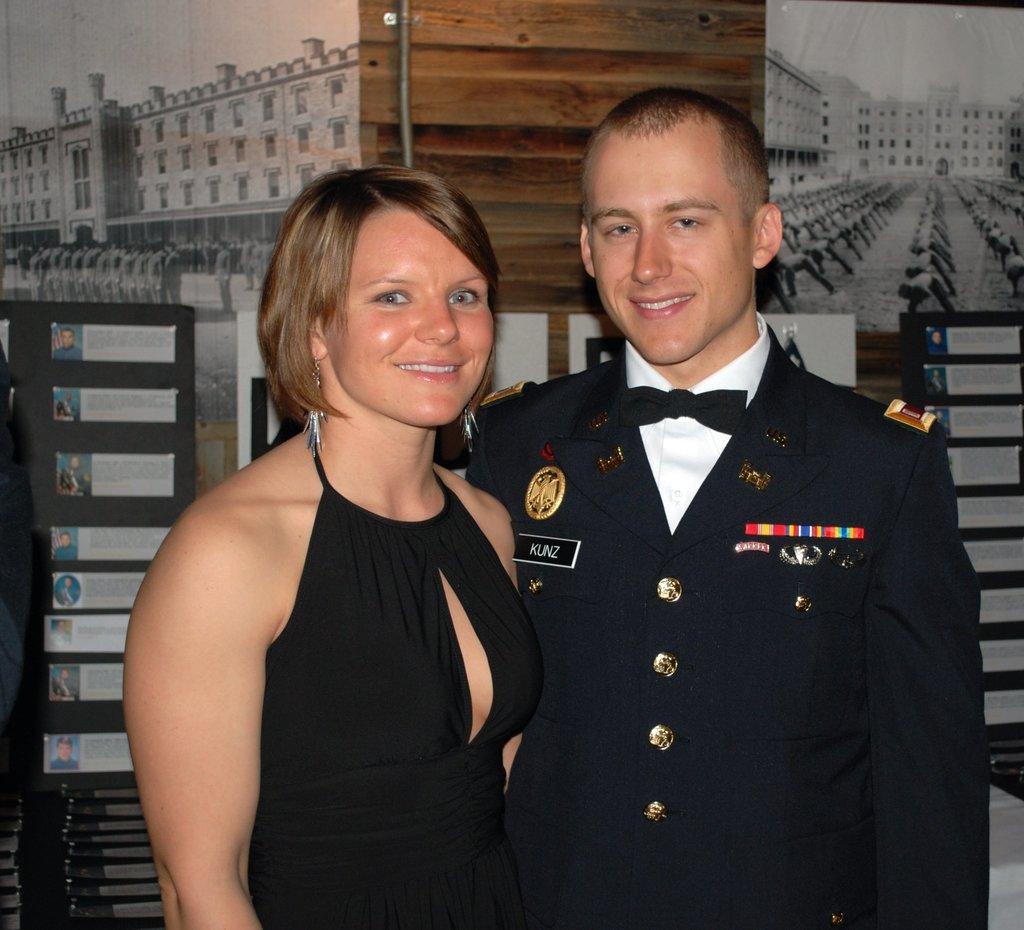Please provide a concise description of this image. This image consists of a man wearing black dress. Beside him, there is a woman also wearing black dress. In the background, there is a wall along with posters. 